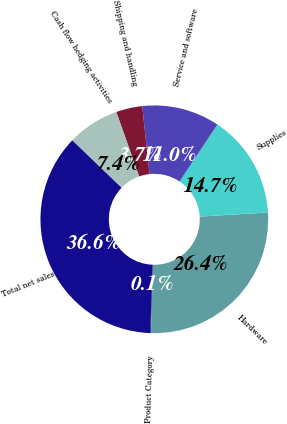<chart> <loc_0><loc_0><loc_500><loc_500><pie_chart><fcel>Product Category<fcel>Hardware<fcel>Supplies<fcel>Service and software<fcel>Shipping and handling<fcel>Cash flow hedging activities<fcel>Total net sales<nl><fcel>0.08%<fcel>26.44%<fcel>14.7%<fcel>11.04%<fcel>3.73%<fcel>7.39%<fcel>36.63%<nl></chart> 